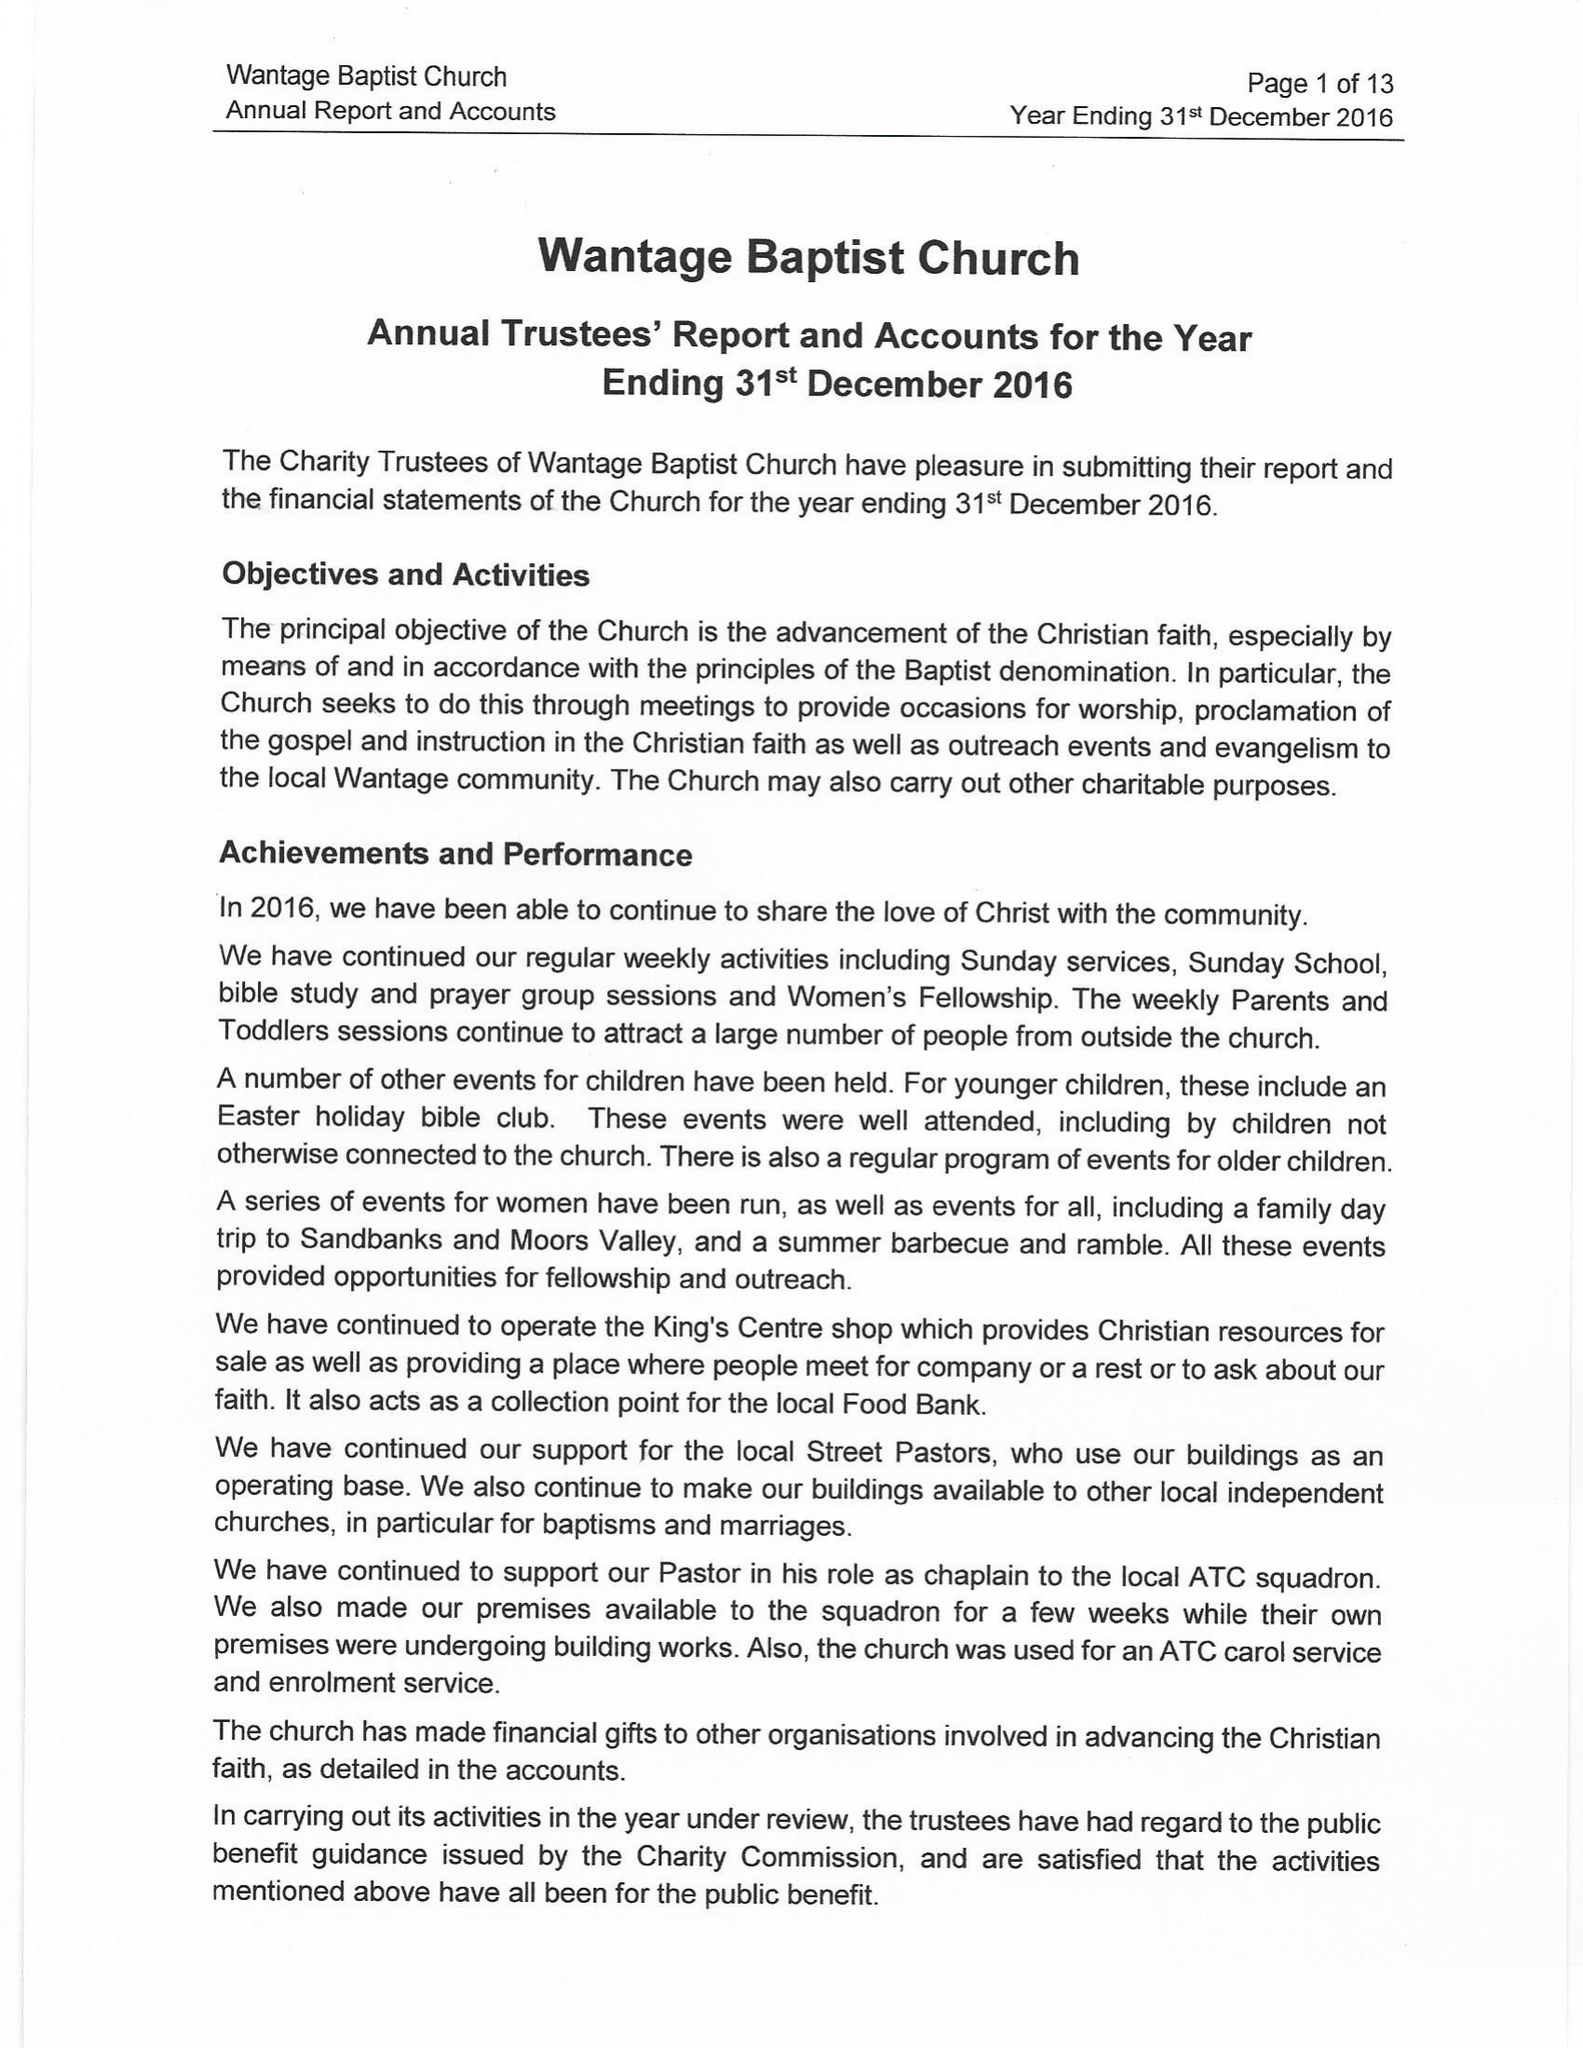What is the value for the address__postcode?
Answer the question using a single word or phrase. OX12 9AQ 